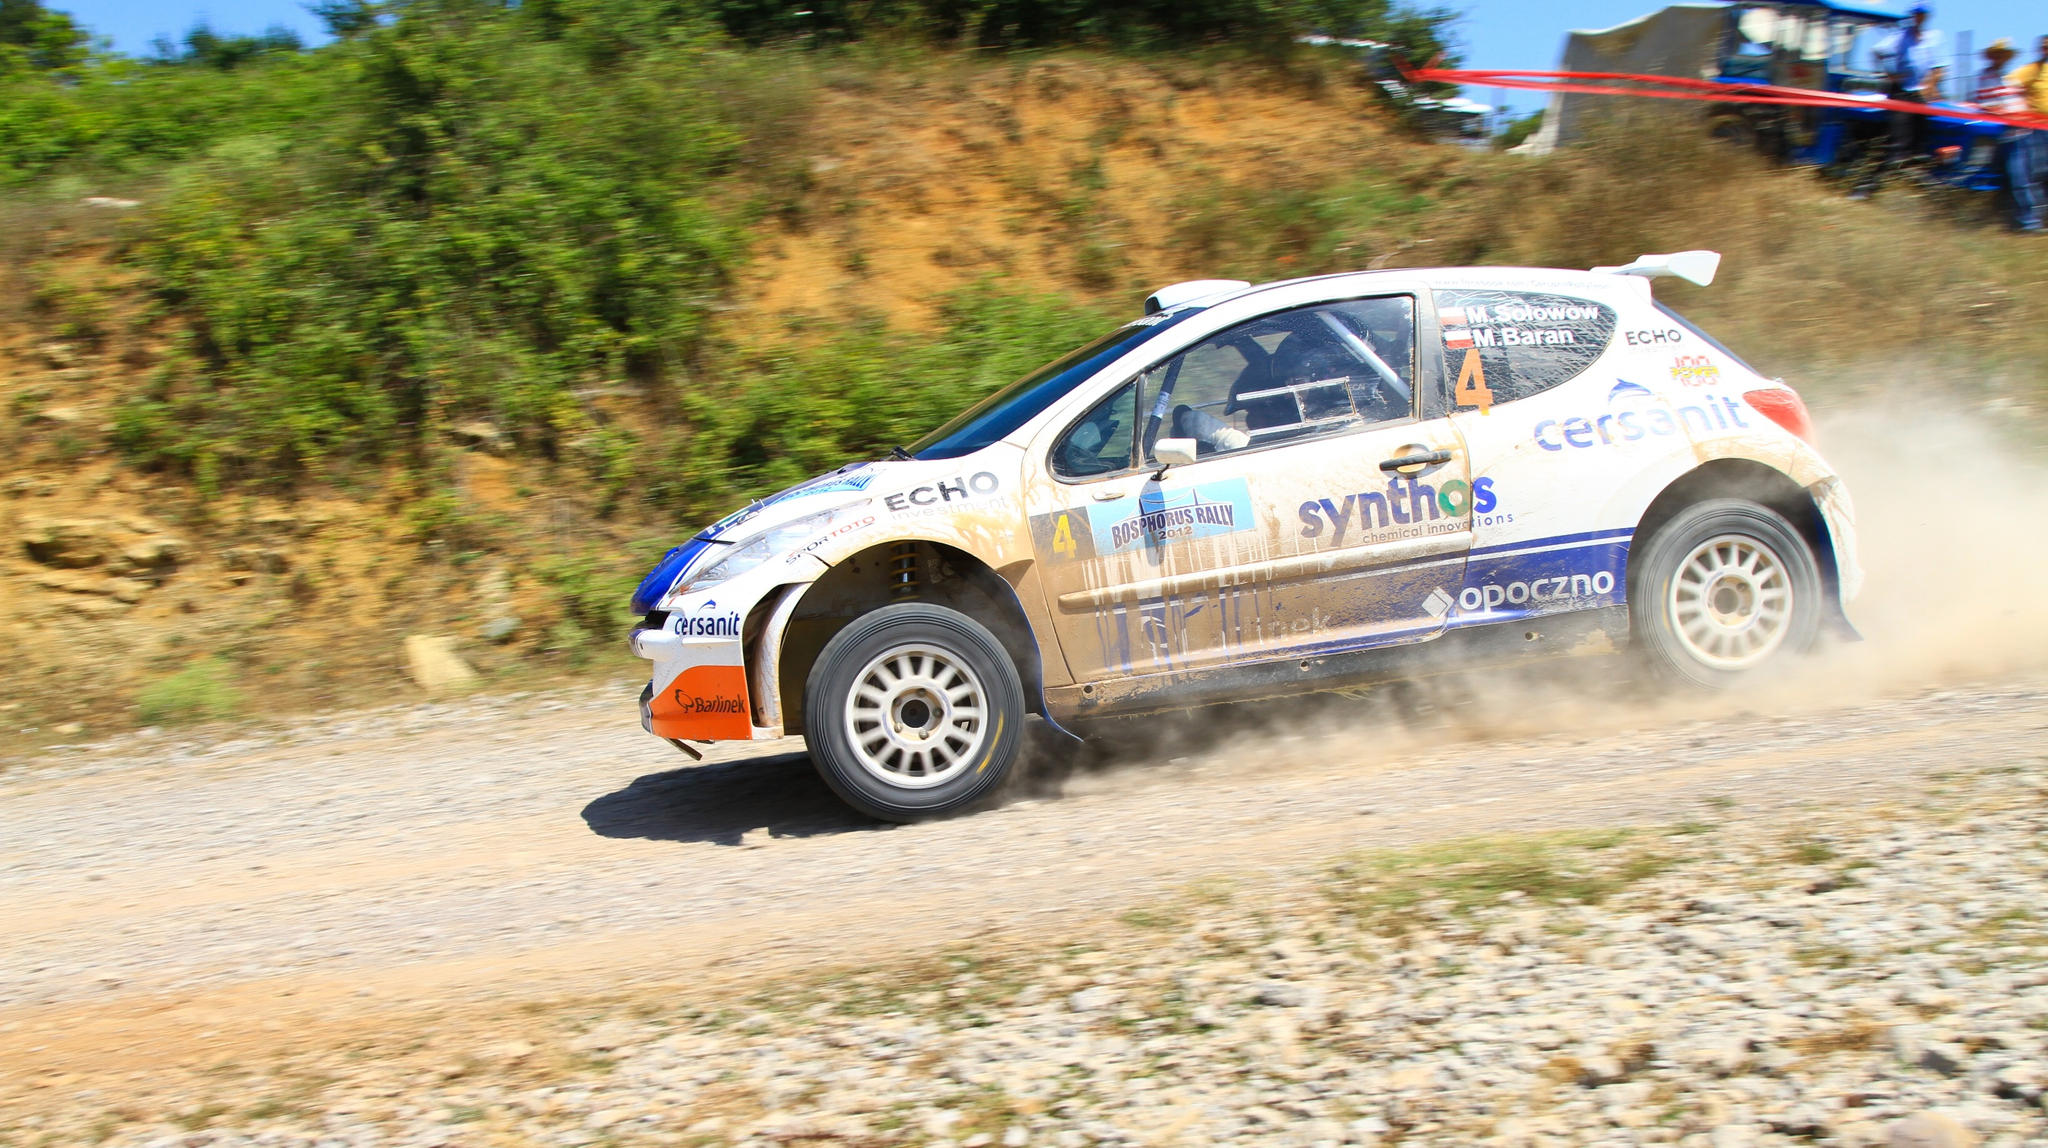Tell me more about the significance of the car's decals. The decals on the rally car, such as 'synthos', 'cersanit', and 'opoczno', represent the sponsors who support the team. These sponsors are crucial as they provide financial backing and resources, enabling the team to participate in events and maintain the high-performance standards needed for competitive racing. Each decal is strategically placed for maximum exposure during races, broadcasts, and photos, illustrating a partnership between the sport of rally racing and these businesses. 